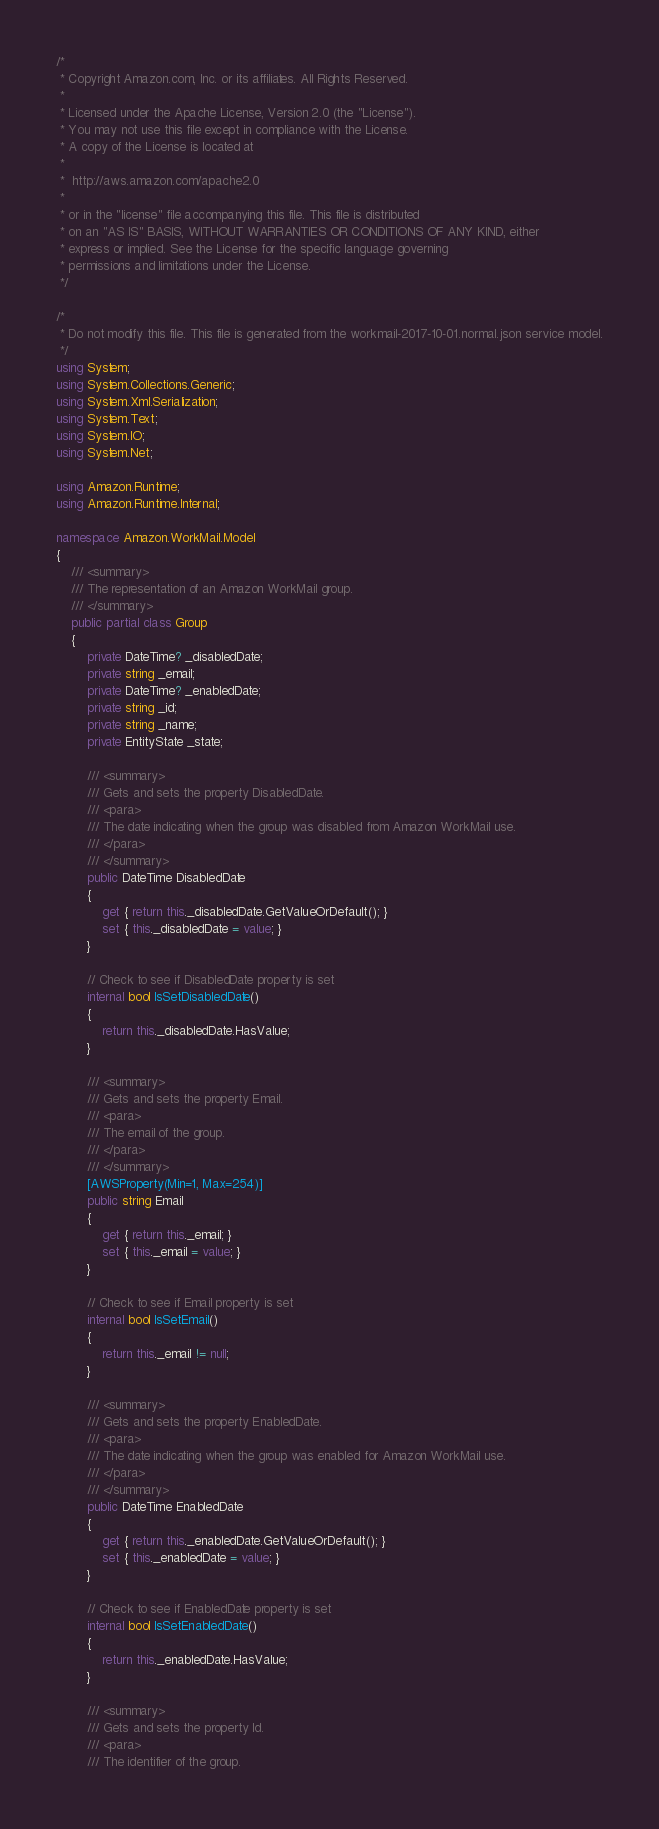Convert code to text. <code><loc_0><loc_0><loc_500><loc_500><_C#_>/*
 * Copyright Amazon.com, Inc. or its affiliates. All Rights Reserved.
 * 
 * Licensed under the Apache License, Version 2.0 (the "License").
 * You may not use this file except in compliance with the License.
 * A copy of the License is located at
 * 
 *  http://aws.amazon.com/apache2.0
 * 
 * or in the "license" file accompanying this file. This file is distributed
 * on an "AS IS" BASIS, WITHOUT WARRANTIES OR CONDITIONS OF ANY KIND, either
 * express or implied. See the License for the specific language governing
 * permissions and limitations under the License.
 */

/*
 * Do not modify this file. This file is generated from the workmail-2017-10-01.normal.json service model.
 */
using System;
using System.Collections.Generic;
using System.Xml.Serialization;
using System.Text;
using System.IO;
using System.Net;

using Amazon.Runtime;
using Amazon.Runtime.Internal;

namespace Amazon.WorkMail.Model
{
    /// <summary>
    /// The representation of an Amazon WorkMail group.
    /// </summary>
    public partial class Group
    {
        private DateTime? _disabledDate;
        private string _email;
        private DateTime? _enabledDate;
        private string _id;
        private string _name;
        private EntityState _state;

        /// <summary>
        /// Gets and sets the property DisabledDate. 
        /// <para>
        /// The date indicating when the group was disabled from Amazon WorkMail use.
        /// </para>
        /// </summary>
        public DateTime DisabledDate
        {
            get { return this._disabledDate.GetValueOrDefault(); }
            set { this._disabledDate = value; }
        }

        // Check to see if DisabledDate property is set
        internal bool IsSetDisabledDate()
        {
            return this._disabledDate.HasValue; 
        }

        /// <summary>
        /// Gets and sets the property Email. 
        /// <para>
        /// The email of the group.
        /// </para>
        /// </summary>
        [AWSProperty(Min=1, Max=254)]
        public string Email
        {
            get { return this._email; }
            set { this._email = value; }
        }

        // Check to see if Email property is set
        internal bool IsSetEmail()
        {
            return this._email != null;
        }

        /// <summary>
        /// Gets and sets the property EnabledDate. 
        /// <para>
        /// The date indicating when the group was enabled for Amazon WorkMail use.
        /// </para>
        /// </summary>
        public DateTime EnabledDate
        {
            get { return this._enabledDate.GetValueOrDefault(); }
            set { this._enabledDate = value; }
        }

        // Check to see if EnabledDate property is set
        internal bool IsSetEnabledDate()
        {
            return this._enabledDate.HasValue; 
        }

        /// <summary>
        /// Gets and sets the property Id. 
        /// <para>
        /// The identifier of the group.</code> 